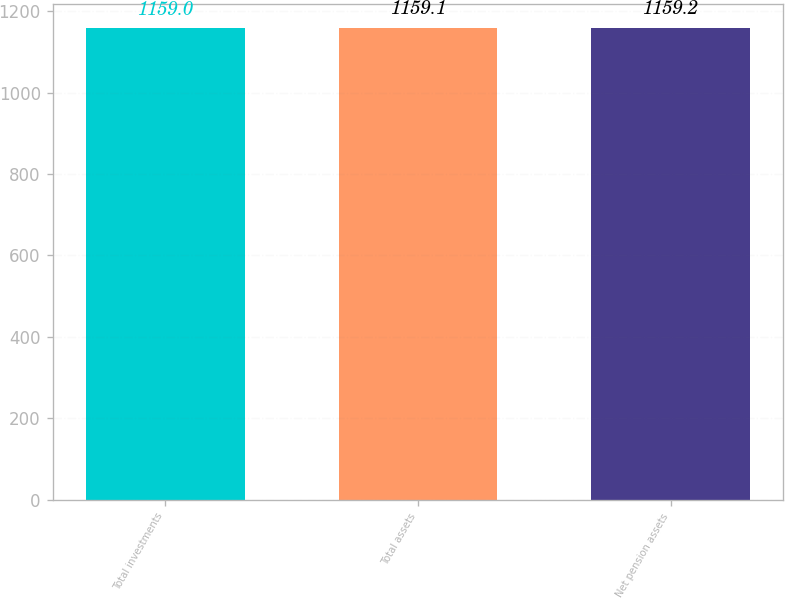Convert chart. <chart><loc_0><loc_0><loc_500><loc_500><bar_chart><fcel>Total investments<fcel>Total assets<fcel>Net pension assets<nl><fcel>1159<fcel>1159.1<fcel>1159.2<nl></chart> 